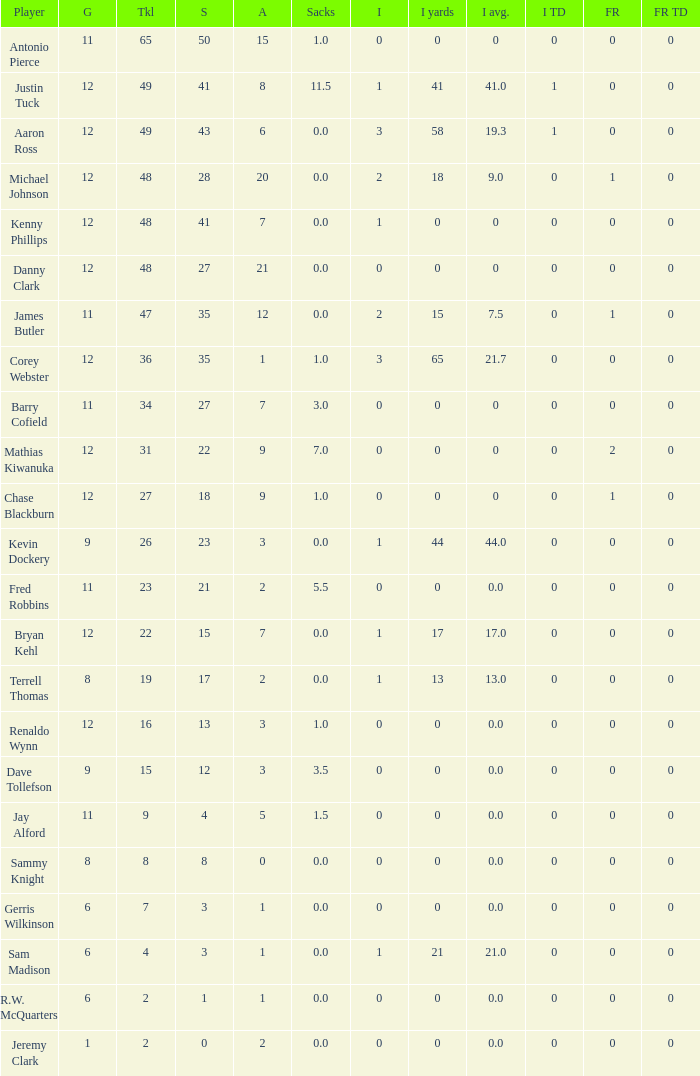Name the least fum rec td 0.0. 